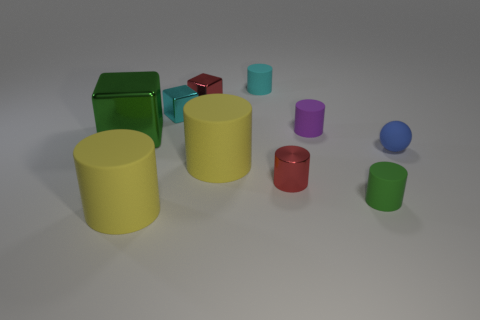Can you describe the size and colors of the objects present in the image? Certainly! There are several cylindrical objects in the image. Two large yellow cylinders, a medium-sized red cylinder, and a small purple cylinder, alongside a small blue sphere. Additionally, there's a small cyan object and two cubes, one large and green, and one tiny and red, visible in the background. 